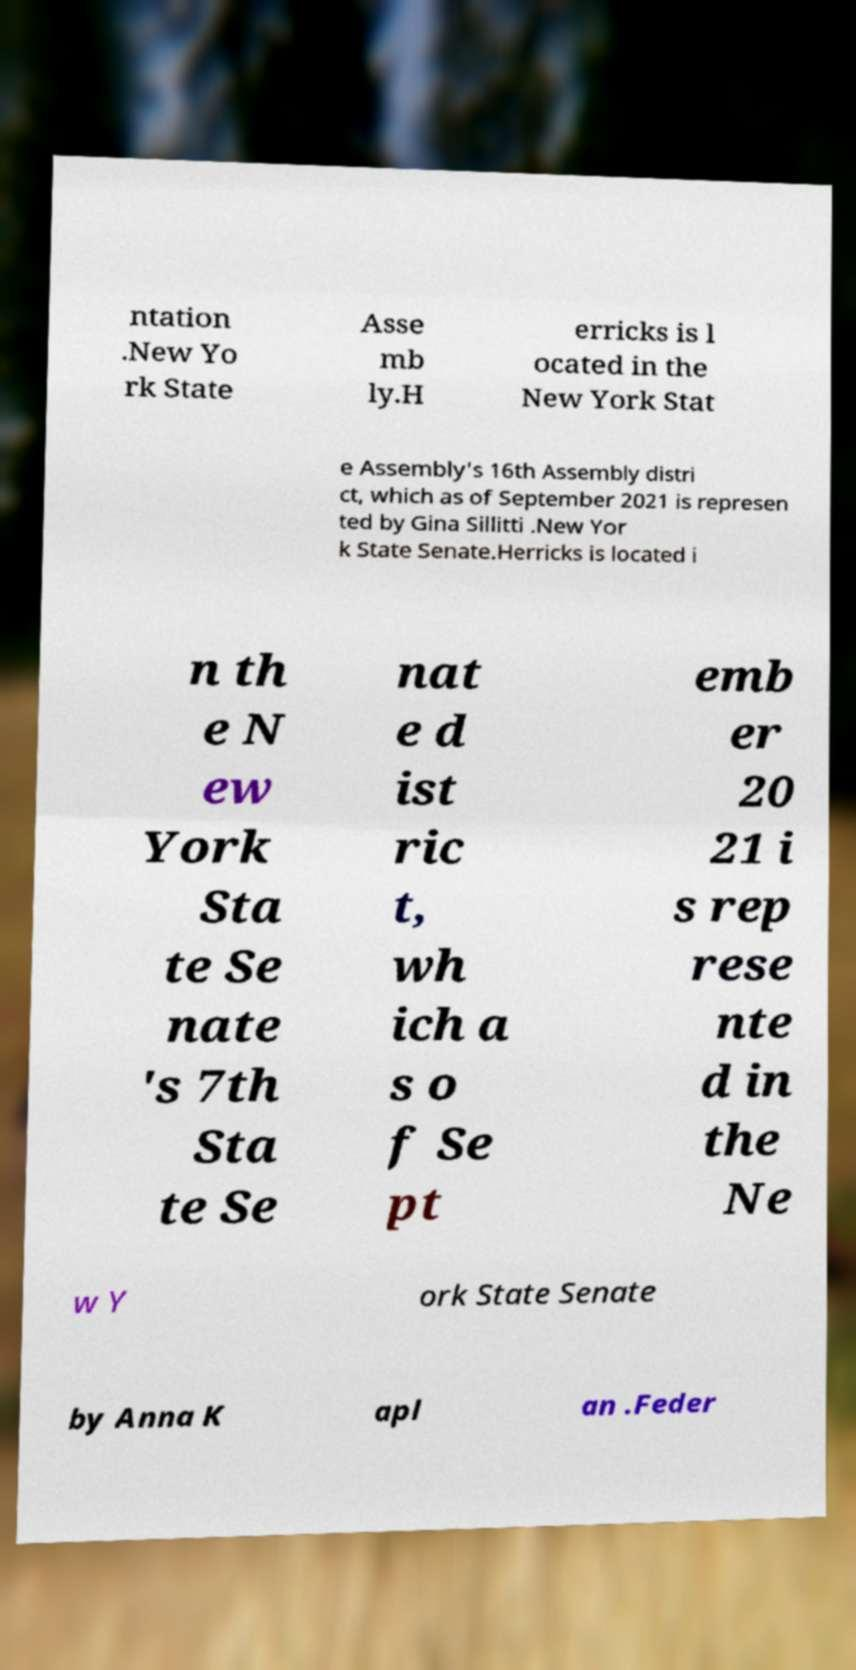Please identify and transcribe the text found in this image. ntation .New Yo rk State Asse mb ly.H erricks is l ocated in the New York Stat e Assembly's 16th Assembly distri ct, which as of September 2021 is represen ted by Gina Sillitti .New Yor k State Senate.Herricks is located i n th e N ew York Sta te Se nate 's 7th Sta te Se nat e d ist ric t, wh ich a s o f Se pt emb er 20 21 i s rep rese nte d in the Ne w Y ork State Senate by Anna K apl an .Feder 